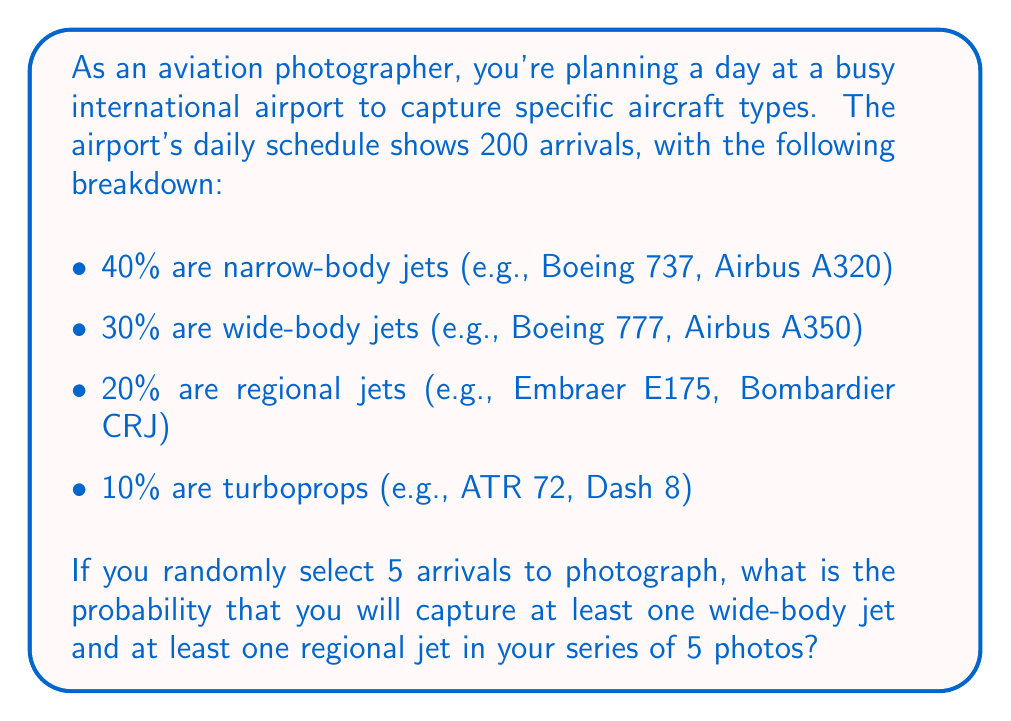Can you answer this question? Let's approach this step-by-step using the concept of complementary events and the multiplication rule of probability.

1) First, let's calculate the probability of NOT getting a wide-body jet in a single photo:
   $P(\text{not wide-body}) = 1 - 0.30 = 0.70$

2) Similarly, for NOT getting a regional jet:
   $P(\text{not regional}) = 1 - 0.20 = 0.80$

3) The probability of not getting at least one wide-body AND not getting at least one regional in 5 photos is:
   $P(\text{no wide-body AND no regional}) = (0.70)^5 \cdot (0.80)^5$

4) This is because we need to NOT get a wide-body 5 times AND NOT get a regional 5 times.

5) Now, the probability we want is the complement of this event:
   $P(\text{at least one wide-body AND at least one regional}) = 1 - P(\text{no wide-body AND no regional})$

6) Let's calculate:
   $P(\text{at least one wide-body AND at least one regional}) = 1 - (0.70)^5 \cdot (0.80)^5$
   $= 1 - (0.16807) \cdot (0.32768)$
   $= 1 - 0.05507$
   $= 0.94493$

Therefore, the probability of capturing at least one wide-body jet and at least one regional jet in a series of 5 random photos is approximately 0.94493 or about 94.49%.
Answer: The probability is approximately 0.94493 or 94.49%. 